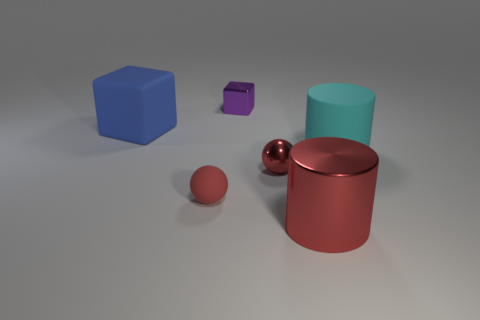Add 3 blue matte objects. How many objects exist? 9 Subtract all spheres. How many objects are left? 4 Add 1 rubber blocks. How many rubber blocks exist? 2 Subtract 0 green cubes. How many objects are left? 6 Subtract all big matte things. Subtract all small balls. How many objects are left? 2 Add 4 red metallic cylinders. How many red metallic cylinders are left? 5 